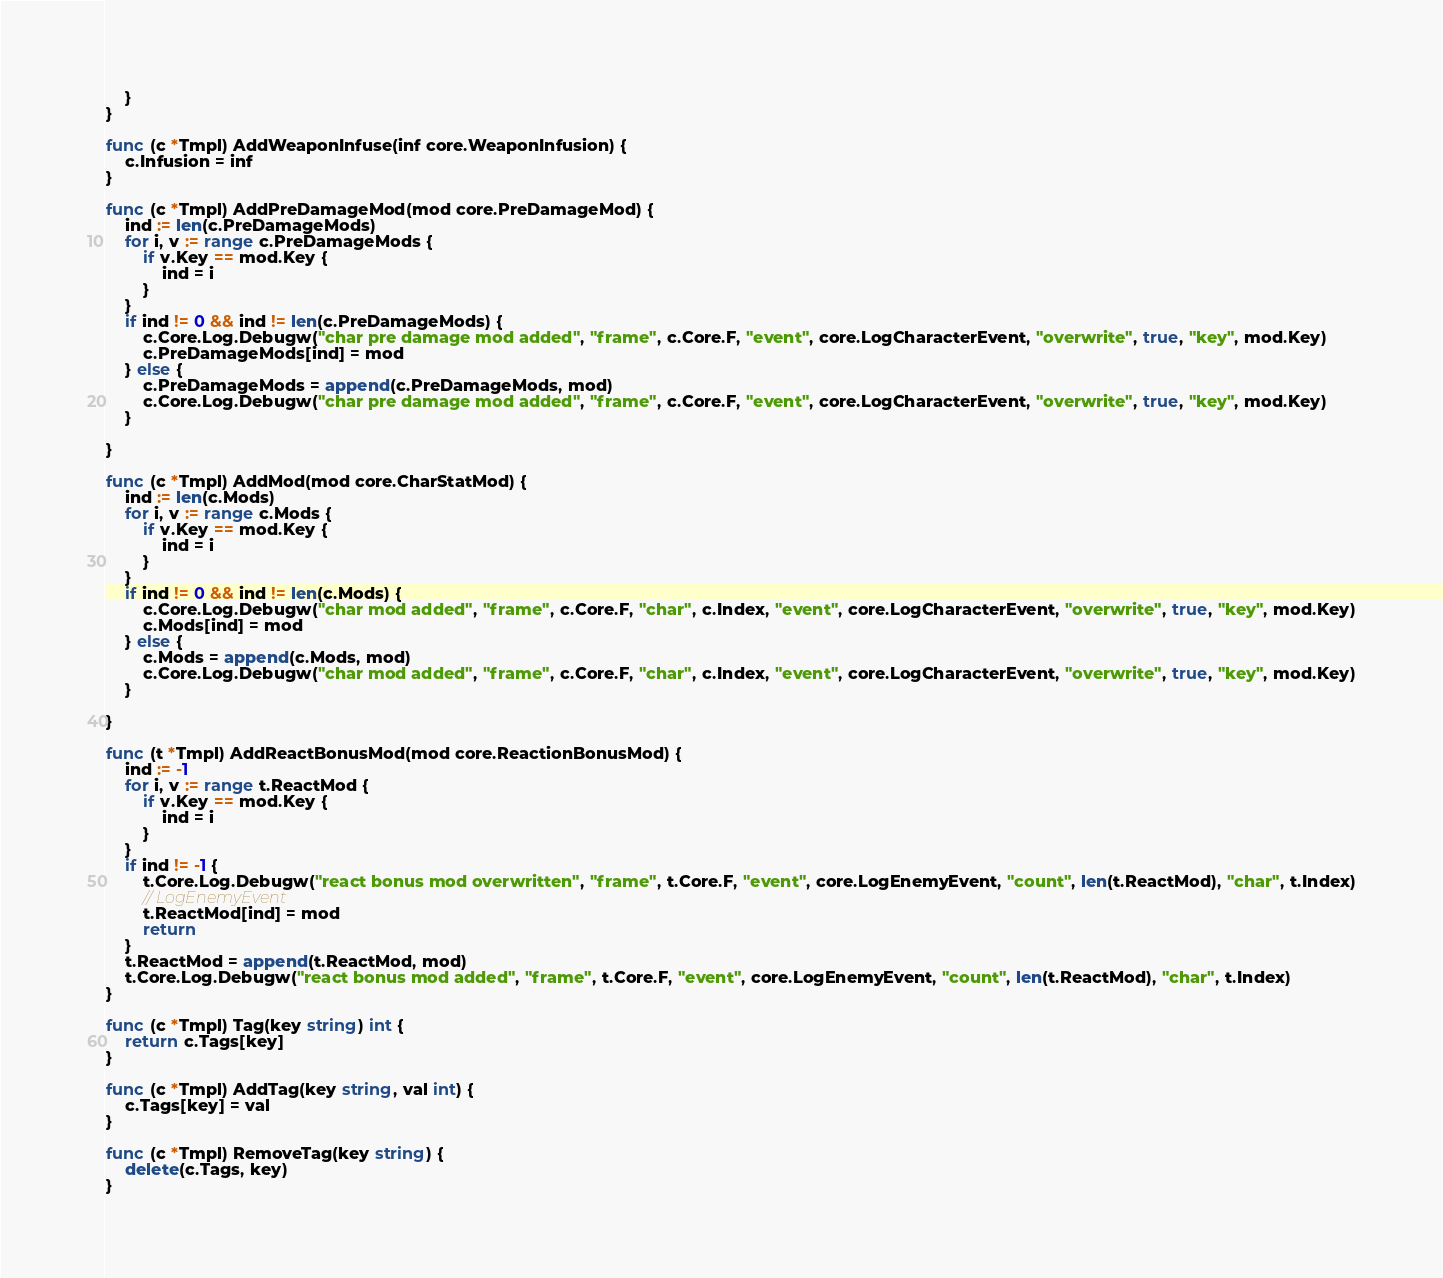<code> <loc_0><loc_0><loc_500><loc_500><_Go_>	}
}

func (c *Tmpl) AddWeaponInfuse(inf core.WeaponInfusion) {
	c.Infusion = inf
}

func (c *Tmpl) AddPreDamageMod(mod core.PreDamageMod) {
	ind := len(c.PreDamageMods)
	for i, v := range c.PreDamageMods {
		if v.Key == mod.Key {
			ind = i
		}
	}
	if ind != 0 && ind != len(c.PreDamageMods) {
		c.Core.Log.Debugw("char pre damage mod added", "frame", c.Core.F, "event", core.LogCharacterEvent, "overwrite", true, "key", mod.Key)
		c.PreDamageMods[ind] = mod
	} else {
		c.PreDamageMods = append(c.PreDamageMods, mod)
		c.Core.Log.Debugw("char pre damage mod added", "frame", c.Core.F, "event", core.LogCharacterEvent, "overwrite", true, "key", mod.Key)
	}

}

func (c *Tmpl) AddMod(mod core.CharStatMod) {
	ind := len(c.Mods)
	for i, v := range c.Mods {
		if v.Key == mod.Key {
			ind = i
		}
	}
	if ind != 0 && ind != len(c.Mods) {
		c.Core.Log.Debugw("char mod added", "frame", c.Core.F, "char", c.Index, "event", core.LogCharacterEvent, "overwrite", true, "key", mod.Key)
		c.Mods[ind] = mod
	} else {
		c.Mods = append(c.Mods, mod)
		c.Core.Log.Debugw("char mod added", "frame", c.Core.F, "char", c.Index, "event", core.LogCharacterEvent, "overwrite", true, "key", mod.Key)
	}

}

func (t *Tmpl) AddReactBonusMod(mod core.ReactionBonusMod) {
	ind := -1
	for i, v := range t.ReactMod {
		if v.Key == mod.Key {
			ind = i
		}
	}
	if ind != -1 {
		t.Core.Log.Debugw("react bonus mod overwritten", "frame", t.Core.F, "event", core.LogEnemyEvent, "count", len(t.ReactMod), "char", t.Index)
		// LogEnemyEvent
		t.ReactMod[ind] = mod
		return
	}
	t.ReactMod = append(t.ReactMod, mod)
	t.Core.Log.Debugw("react bonus mod added", "frame", t.Core.F, "event", core.LogEnemyEvent, "count", len(t.ReactMod), "char", t.Index)
}

func (c *Tmpl) Tag(key string) int {
	return c.Tags[key]
}

func (c *Tmpl) AddTag(key string, val int) {
	c.Tags[key] = val
}

func (c *Tmpl) RemoveTag(key string) {
	delete(c.Tags, key)
}
</code> 